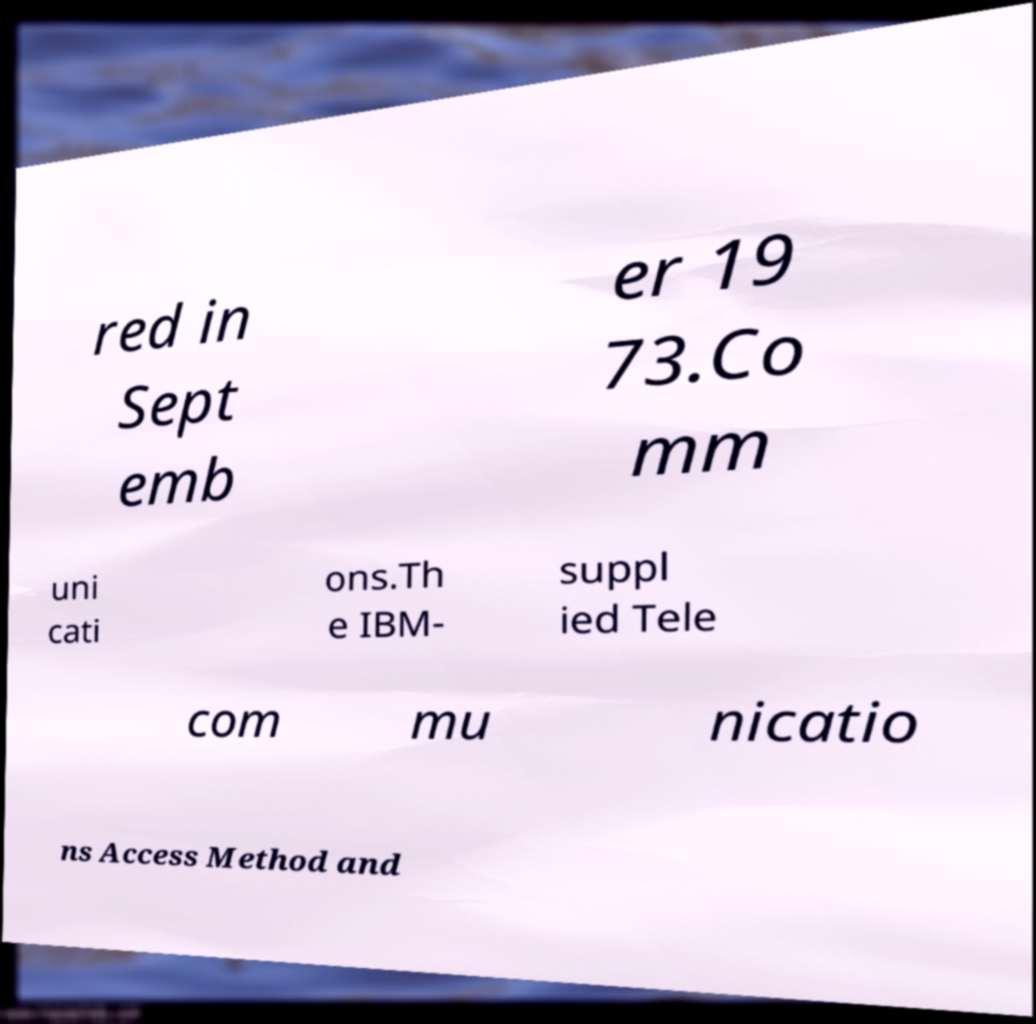Could you extract and type out the text from this image? red in Sept emb er 19 73.Co mm uni cati ons.Th e IBM- suppl ied Tele com mu nicatio ns Access Method and 